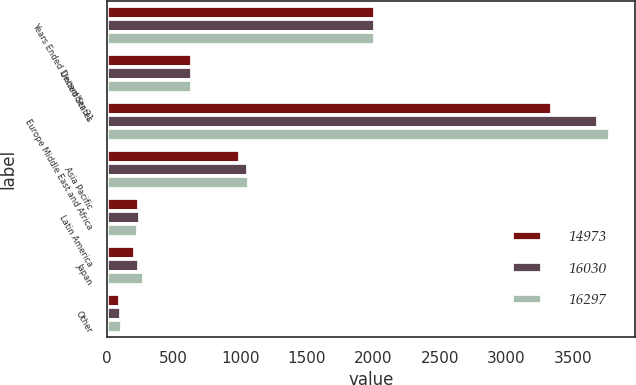Convert chart. <chart><loc_0><loc_0><loc_500><loc_500><stacked_bar_chart><ecel><fcel>Years Ended December 31<fcel>United States<fcel>Europe Middle East and Africa<fcel>Asia Pacific<fcel>Latin America<fcel>Japan<fcel>Other<nl><fcel>14973<fcel>2013<fcel>640<fcel>3346<fcel>1001<fcel>242<fcel>211<fcel>97<nl><fcel>16030<fcel>2012<fcel>640<fcel>3688<fcel>1059<fcel>250<fcel>243<fcel>103<nl><fcel>16297<fcel>2011<fcel>640<fcel>3780<fcel>1064<fcel>234<fcel>279<fcel>114<nl></chart> 